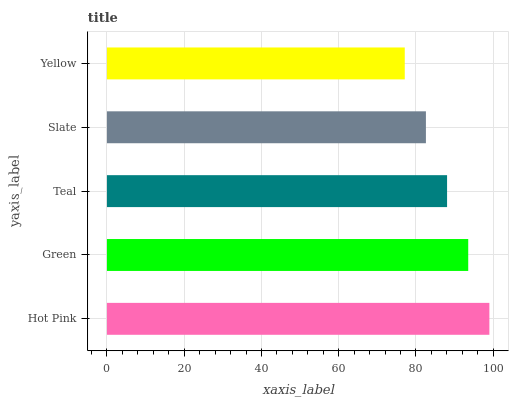Is Yellow the minimum?
Answer yes or no. Yes. Is Hot Pink the maximum?
Answer yes or no. Yes. Is Green the minimum?
Answer yes or no. No. Is Green the maximum?
Answer yes or no. No. Is Hot Pink greater than Green?
Answer yes or no. Yes. Is Green less than Hot Pink?
Answer yes or no. Yes. Is Green greater than Hot Pink?
Answer yes or no. No. Is Hot Pink less than Green?
Answer yes or no. No. Is Teal the high median?
Answer yes or no. Yes. Is Teal the low median?
Answer yes or no. Yes. Is Hot Pink the high median?
Answer yes or no. No. Is Hot Pink the low median?
Answer yes or no. No. 